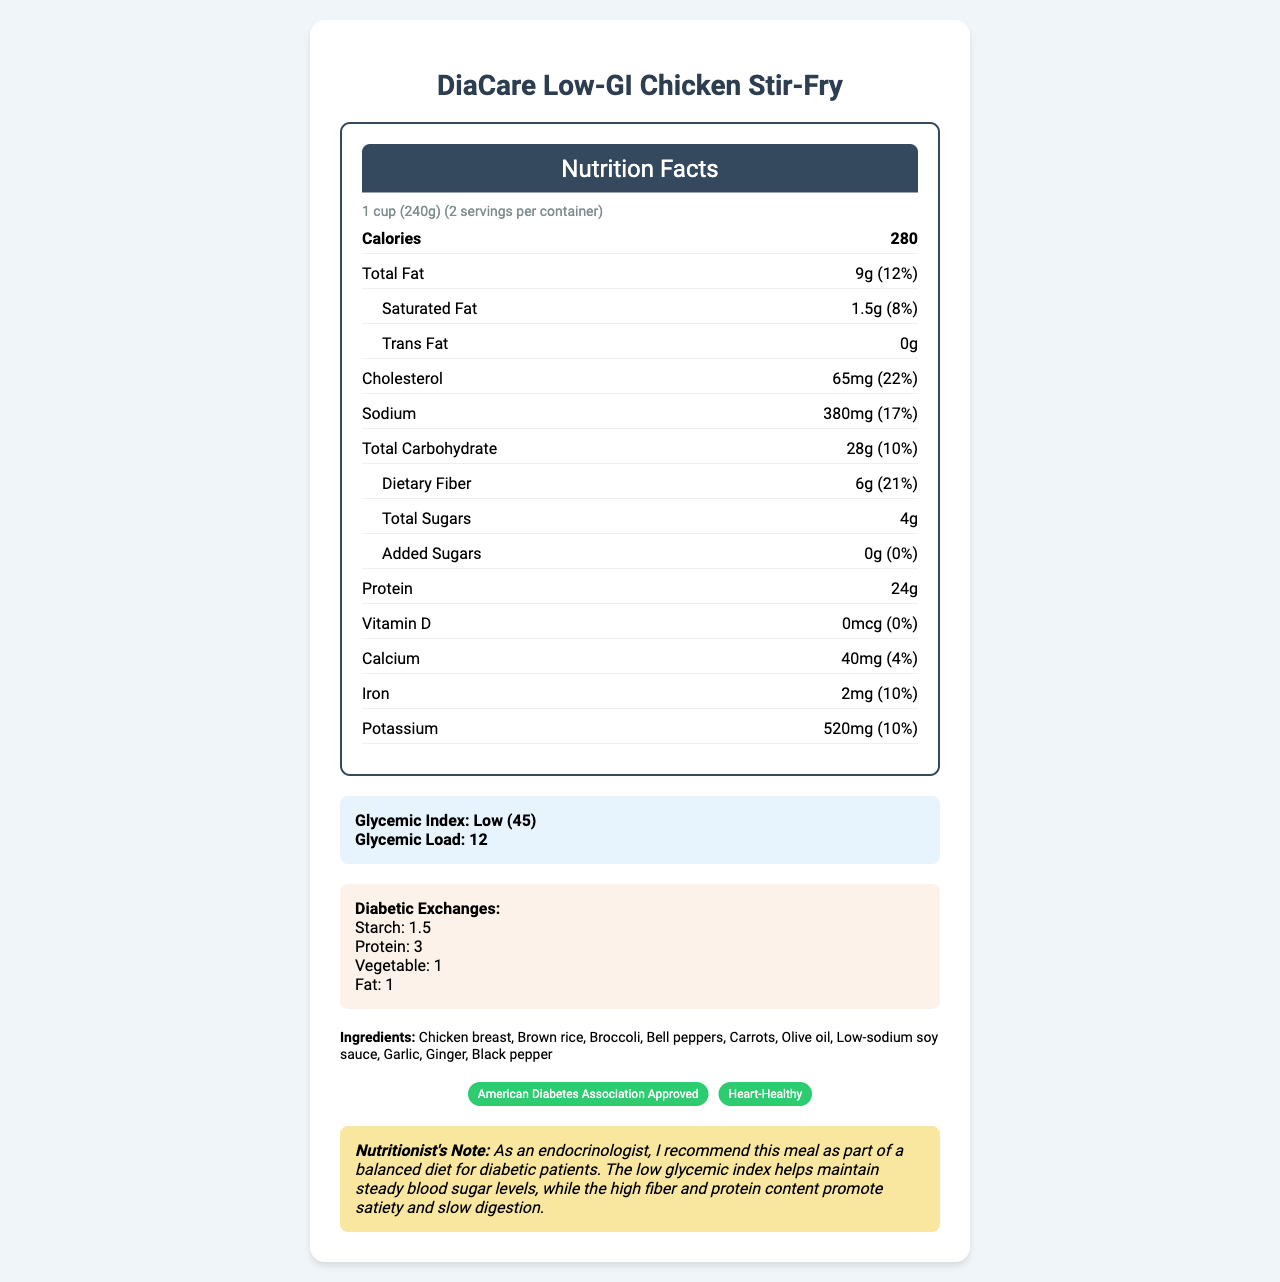what is the serving size of DiaCare Low-GI Chicken Stir-Fry? The serving size is explicitly stated at the beginning of the document.
Answer: 1 cup (240g) how many calories are there per serving? The calorie content per serving is clearly listed right under the serving size.
Answer: 280 calories what is the total amount of dietary fiber? The total dietary fiber for each serving is listed under the total carbohydrate section.
Answer: 6g what is the percentage of daily value for sodium per serving? The daily value percentage for sodium per serving is provided alongside its amount.
Answer: 17% how much protein is in one serving of DiaCare Low-GI Chicken Stir-Fry? The protein content per serving is explicitly mentioned in the nutrition facts.
Answer: 24g which of the following ingredients is included in the DiaCare Low-GI Chicken Stir-Fry? A. Almonds B. Chicken breast C. Tofu The ingredient list clearly includes "Chicken breast."
Answer: B. Chicken breast what is the preparation tip given for optimal blood sugar management? A. Pair with a side salad B. Pair with a high-fat dessert C. Consume raw The preparation tips section advises to pair the meal with a side salad for optimal blood sugar management.
Answer: A. Pair with a side salad what certifications does this product have? A. American Diabetes Association Approved B. Gluten-Free C. Organic The certifications listed include "American Diabetes Association Approved" and "Heart-Healthy."
Answer: A. American Diabetes Association Approved is the product gluten-free according to the nutrition facts label? The document does not mention anything about the product being gluten-free.
Answer: No summarize the main purpose of this nutrition facts label. The description outlines all the key components of the label, emphasizing its focus on helping diabetic patients maintain steady blood sugar levels and make informed dietary choices.
Answer: The label provides detailed nutritional information for the DiaCare Low-GI Chicken Stir-Fry, which is designed for diabetic patients. It highlights the serving size, calories, fat, carbohydrates, fiber, protein, vitamins, and minerals, along with preparation tips, certifications, and an allergen alert. what is the glycemic load of this meal? The glycemic load is stated in the glycemic info section.
Answer: 12 what is the contact number for the manufacturer? The contact number is listed in the manufacturer info section.
Answer: 1-800-DIABETES who is the nutritionist recommending this meal? The label includes a recommendation from an endocrinologist but does not provide the nutritionist's name.
Answer: Not enough information 